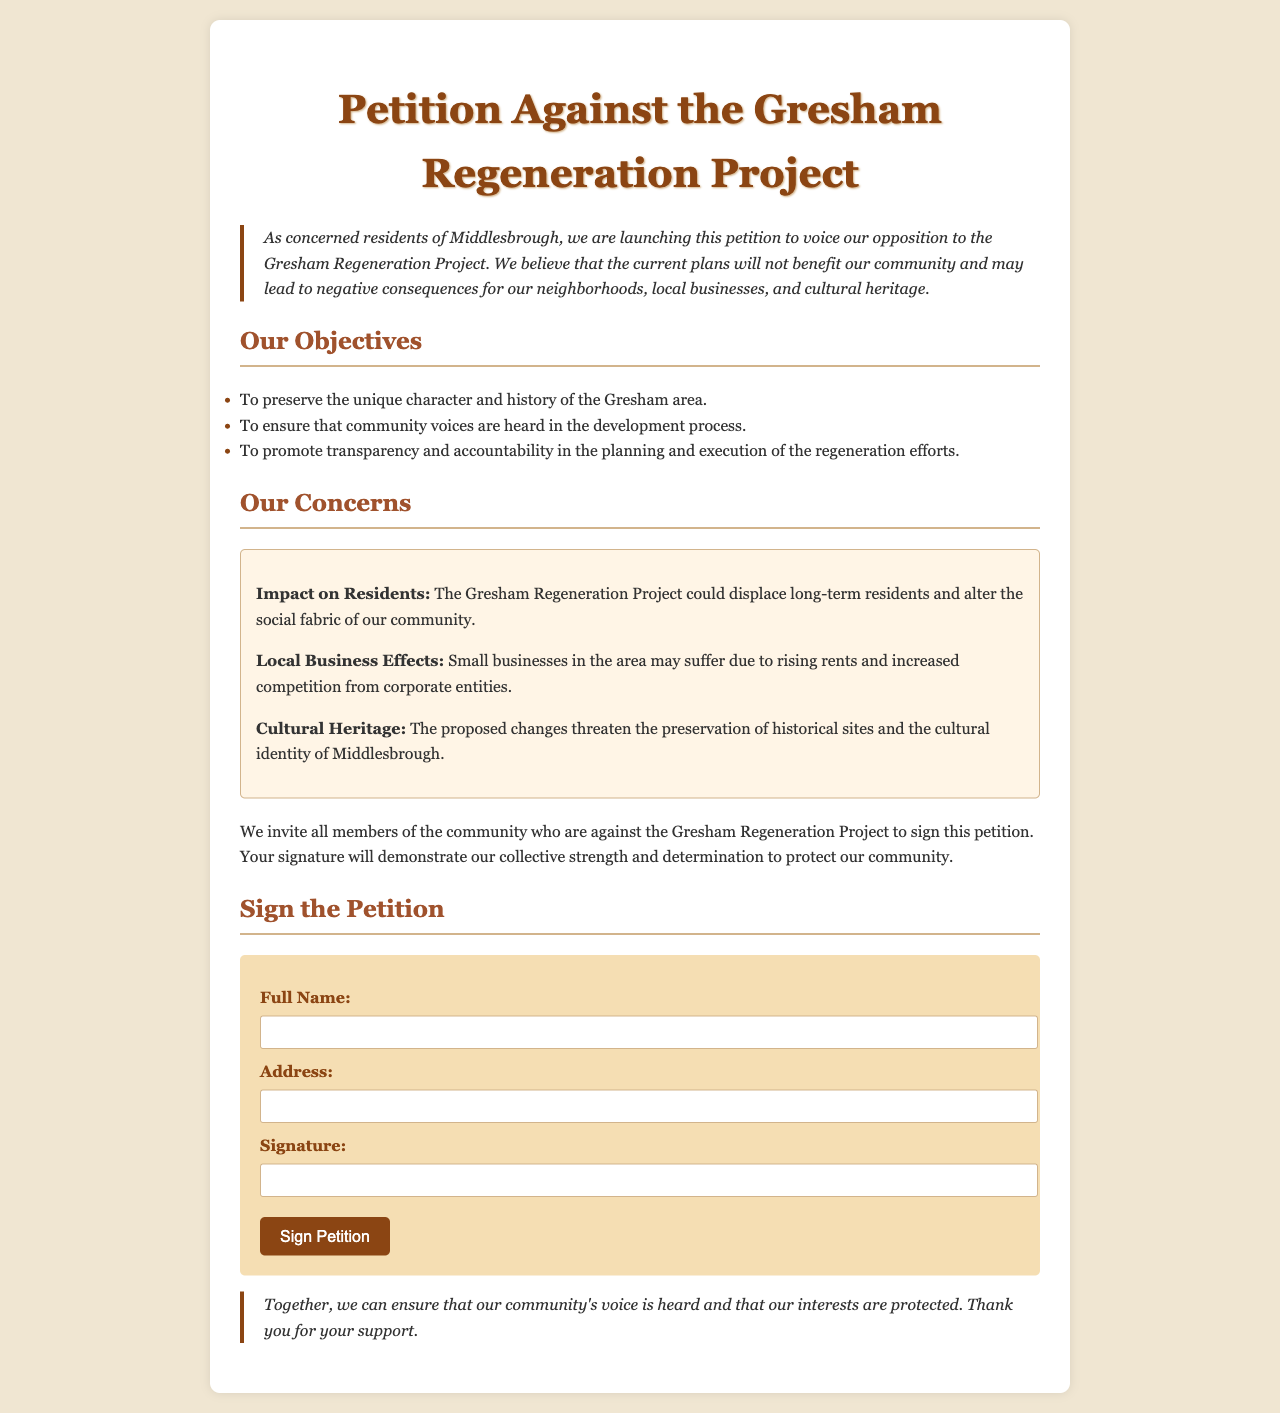What is the title of the document? The title of the document is reflected in the header section of the document.
Answer: Petition Against the Gresham Regeneration Project What is the objective of the petition? One of the key objectives outlined in the document is about community engagement in the development process.
Answer: To ensure that community voices are heard in the development process What concern relates to local businesses? This concern relates to the negative impacts that the regeneration project may have on small businesses within the area.
Answer: Small businesses in the area may suffer due to rising rents and increased competition from corporate entities What color is used for the main heading? The color of the main heading is mentioned in the style section of the document.
Answer: #8b4513 How many main objectives are listed in the document? The document clearly outlines a list of main objectives for the petition, which can be counted.
Answer: Three What type of response is the petition seeking? The petition is seeking a specific action from community members as indicated in the concluding sections of the document.
Answer: Signatures What is mentioned about cultural heritage in the concerns? This concern addresses the potential impact on the historical and cultural aspects of the region.
Answer: The proposed changes threaten the preservation of historical sites and the cultural identity of Middlesbrough What is the background color of the form section? The background color of the form is specified in the style section of the document.
Answer: #f5deb3 How does the document invite community members to engage? The document provides a clear call to action where community members are encouraged to take part.
Answer: To sign the petition 